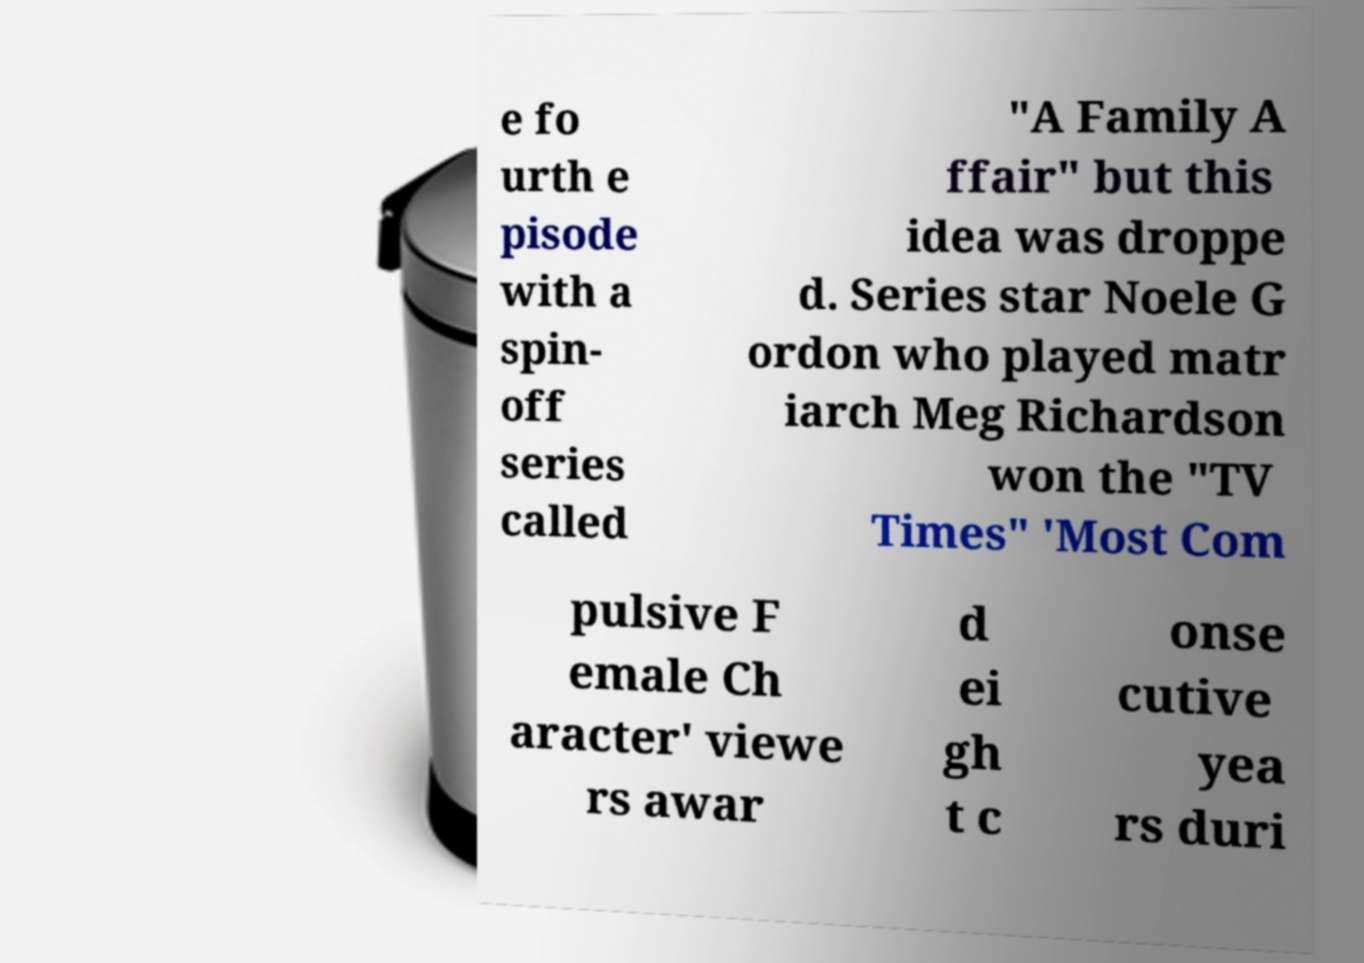Can you accurately transcribe the text from the provided image for me? e fo urth e pisode with a spin- off series called "A Family A ffair" but this idea was droppe d. Series star Noele G ordon who played matr iarch Meg Richardson won the "TV Times" 'Most Com pulsive F emale Ch aracter' viewe rs awar d ei gh t c onse cutive yea rs duri 